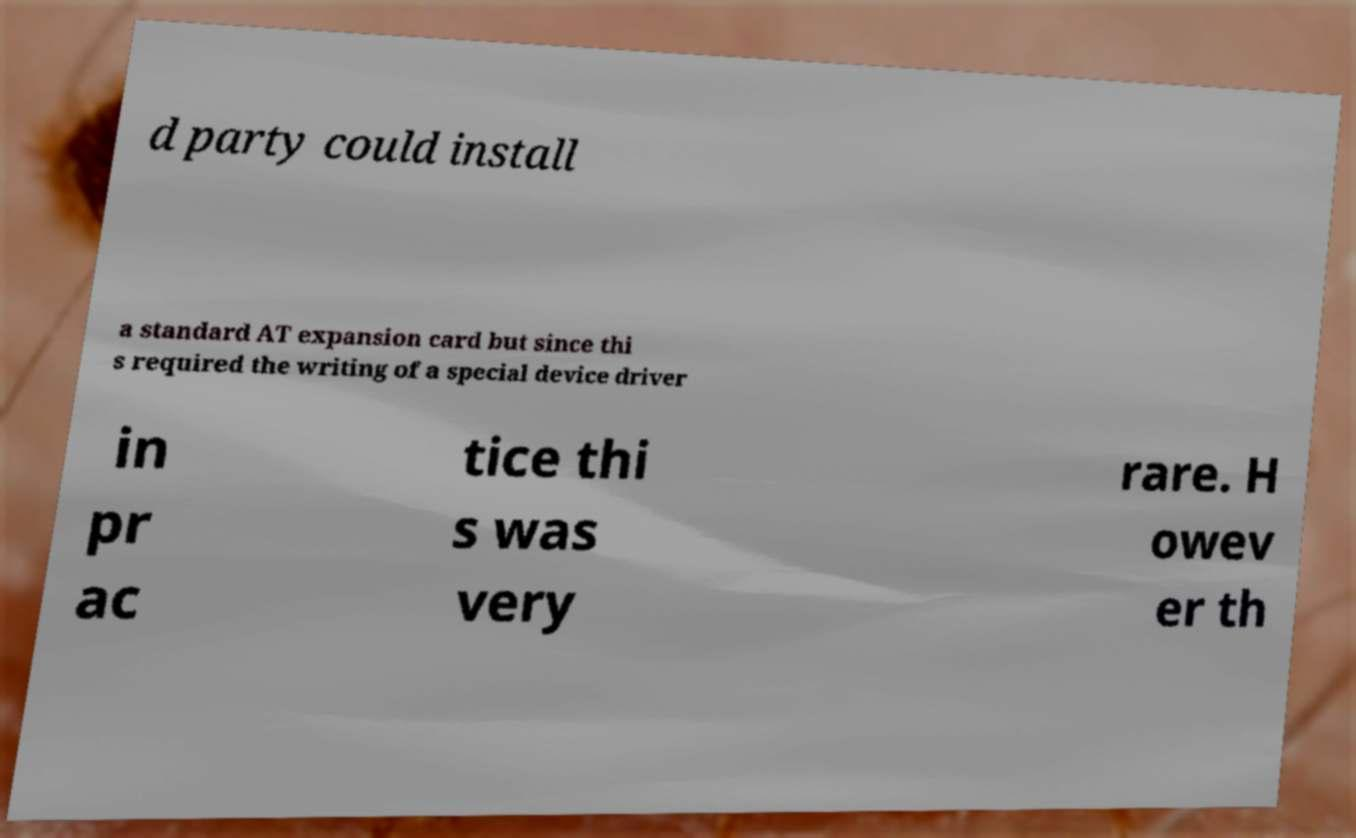What messages or text are displayed in this image? I need them in a readable, typed format. d party could install a standard AT expansion card but since thi s required the writing of a special device driver in pr ac tice thi s was very rare. H owev er th 